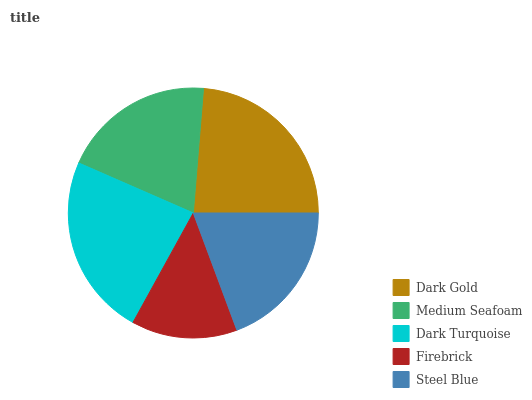Is Firebrick the minimum?
Answer yes or no. Yes. Is Dark Gold the maximum?
Answer yes or no. Yes. Is Medium Seafoam the minimum?
Answer yes or no. No. Is Medium Seafoam the maximum?
Answer yes or no. No. Is Dark Gold greater than Medium Seafoam?
Answer yes or no. Yes. Is Medium Seafoam less than Dark Gold?
Answer yes or no. Yes. Is Medium Seafoam greater than Dark Gold?
Answer yes or no. No. Is Dark Gold less than Medium Seafoam?
Answer yes or no. No. Is Medium Seafoam the high median?
Answer yes or no. Yes. Is Medium Seafoam the low median?
Answer yes or no. Yes. Is Firebrick the high median?
Answer yes or no. No. Is Dark Turquoise the low median?
Answer yes or no. No. 